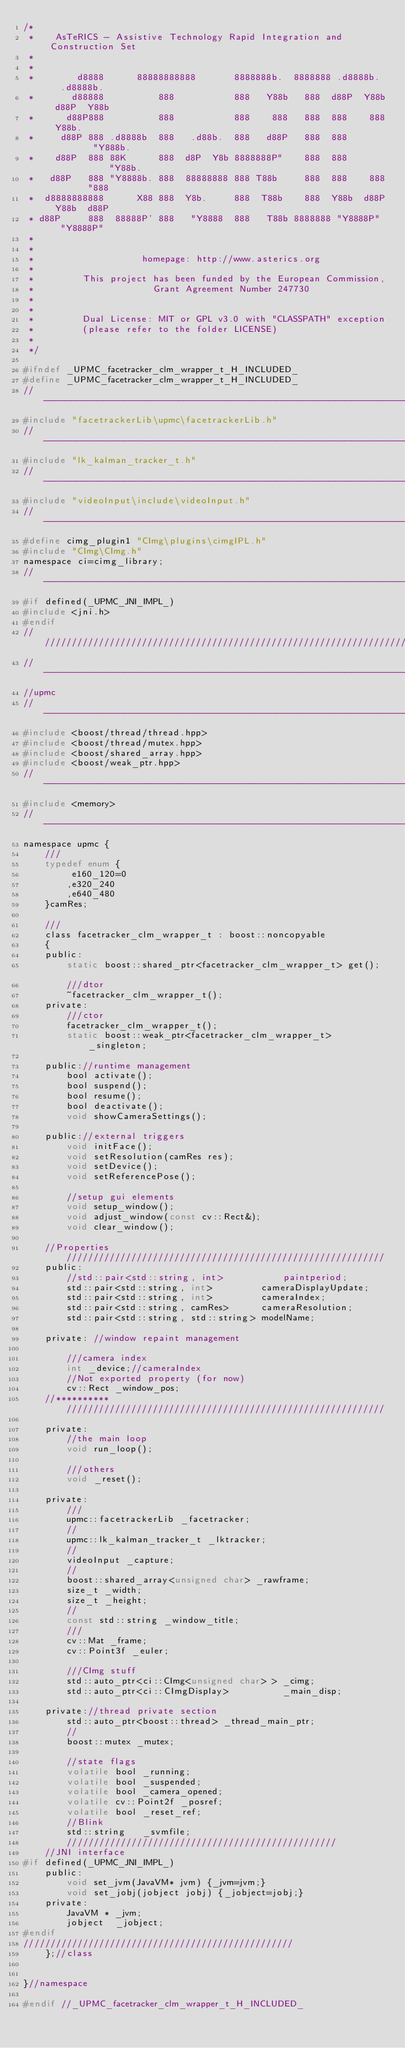<code> <loc_0><loc_0><loc_500><loc_500><_C_>/*
 *    AsTeRICS - Assistive Technology Rapid Integration and Construction Set
 * 
 * 
 *        d8888      88888888888       8888888b.  8888888 .d8888b.   .d8888b. 
 *       d88888          888           888   Y88b   888  d88P  Y88b d88P  Y88b
 *      d88P888          888           888    888   888  888    888 Y88b.     
 *     d88P 888 .d8888b  888   .d88b.  888   d88P   888  888         "Y888b.  
 *    d88P  888 88K      888  d8P  Y8b 8888888P"    888  888            "Y88b.
 *   d88P   888 "Y8888b. 888  88888888 888 T88b     888  888    888       "888
 *  d8888888888      X88 888  Y8b.     888  T88b    888  Y88b  d88P Y88b  d88P
 * d88P     888  88888P' 888   "Y8888  888   T88b 8888888 "Y8888P"   "Y8888P" 
 *
 *
 *                    homepage: http://www.asterics.org 
 *
 *         This project has been funded by the European Commission, 
 *                      Grant Agreement Number 247730
 *  
 *  
 *         Dual License: MIT or GPL v3.0 with "CLASSPATH" exception
 *         (please refer to the folder LICENSE)
 * 
 */

#ifndef _UPMC_facetracker_clm_wrapper_t_H_INCLUDED_
#define _UPMC_facetracker_clm_wrapper_t_H_INCLUDED_
//-------------------------------------------------------------------------++
#include "facetrackerLib\upmc\facetrackerLib.h"
//-------------------------------------------------------------------------++
#include "lk_kalman_tracker_t.h"
//-------------------------------------------------------------------------++
#include "videoInput\include\videoInput.h"
//-------------------------------------------------------------------------++
#define cimg_plugin1 "CImg\plugins\cimgIPL.h"
#include "CImg\CImg.h"
namespace ci=cimg_library;
//-------------------------------------------------------------------------++
#if defined(_UPMC_JNI_IMPL_)
#include <jni.h>
#endif
////////////////////////////////////////////////////////////////////////////
//-------------------------------------------------------------------------++
//upmc
//-------------------------------------------------------------------------++
#include <boost/thread/thread.hpp>
#include <boost/thread/mutex.hpp>
#include <boost/shared_array.hpp>
#include <boost/weak_ptr.hpp>
//-------------------------------------------------------------------------++
#include <memory>
//-------------------------------------------------------------------------++
namespace upmc {
	///
	typedef enum {
		 e160_120=0
		,e320_240
		,e640_480
	}camRes;

	///
	class facetracker_clm_wrapper_t : boost::noncopyable
	{
	public:
		static boost::shared_ptr<facetracker_clm_wrapper_t> get();		
		///dtor
		~facetracker_clm_wrapper_t();
	private:
		///ctor
		facetracker_clm_wrapper_t();
		static boost::weak_ptr<facetracker_clm_wrapper_t> _singleton;

	public://runtime management
		bool activate();
		bool suspend();
		bool resume();
		bool deactivate();
		void showCameraSettings();

	public://external triggers
		void initFace();
		void setResolution(camRes res);
		void setDevice();
		void setReferencePose();

		//setup gui elements
		void setup_window();
		void adjust_window(const cv::Rect&);
		void clear_window();

	//Properties ///////////////////////////////////////////////////////////
	public:
		//std::pair<std::string, int>			paintperiod;
		std::pair<std::string, int>			cameraDisplayUpdate;
		std::pair<std::string, int>			cameraIndex;
		std::pair<std::string, camRes>		cameraResolution;
		std::pair<std::string, std::string>	modelName;

	private: //window repaint management

		///camera index
		int _device;//cameraIndex
		//Not exported property (for now)
		cv::Rect _window_pos;
	//********** ///////////////////////////////////////////////////////////

	private:
		//the main loop
		void run_loop();

		///others
		void _reset();

	private:
		///
		upmc::facetrackerLib _facetracker;
		//
		upmc::lk_kalman_tracker_t _lktracker;
		//
		videoInput _capture;
		//
		boost::shared_array<unsigned char> _rawframe;
		size_t _width;
		size_t _height;
		//
		const std::string _window_title;
		///
		cv::Mat _frame;
		cv::Point3f _euler;

		///CImg stuff
		std::auto_ptr<ci::CImg<unsigned char> > _cimg;
		std::auto_ptr<ci::CImgDisplay>			_main_disp;

	private://thread private section
		std::auto_ptr<boost::thread> _thread_main_ptr;
		//
		boost::mutex _mutex;

		//state flags
		volatile bool _running;
		volatile bool _suspended;
		volatile bool _camera_opened;
		volatile cv::Point2f _posref;
		volatile bool _reset_ref;
		//Blink
		std::string	  _svmfile;
		//////////////////////////////////////////////////
	//JNI interface
#if defined(_UPMC_JNI_IMPL_)
	public:
		void set_jvm(JavaVM* jvm) {_jvm=jvm;}
		void set_jobj(jobject jobj) {_jobject=jobj;}
	private:
		JavaVM * _jvm;
		jobject  _jobject;
#endif
//////////////////////////////////////////////////
	};//class


}//namespace

#endif //_UPMC_facetracker_clm_wrapper_t_H_INCLUDED_</code> 